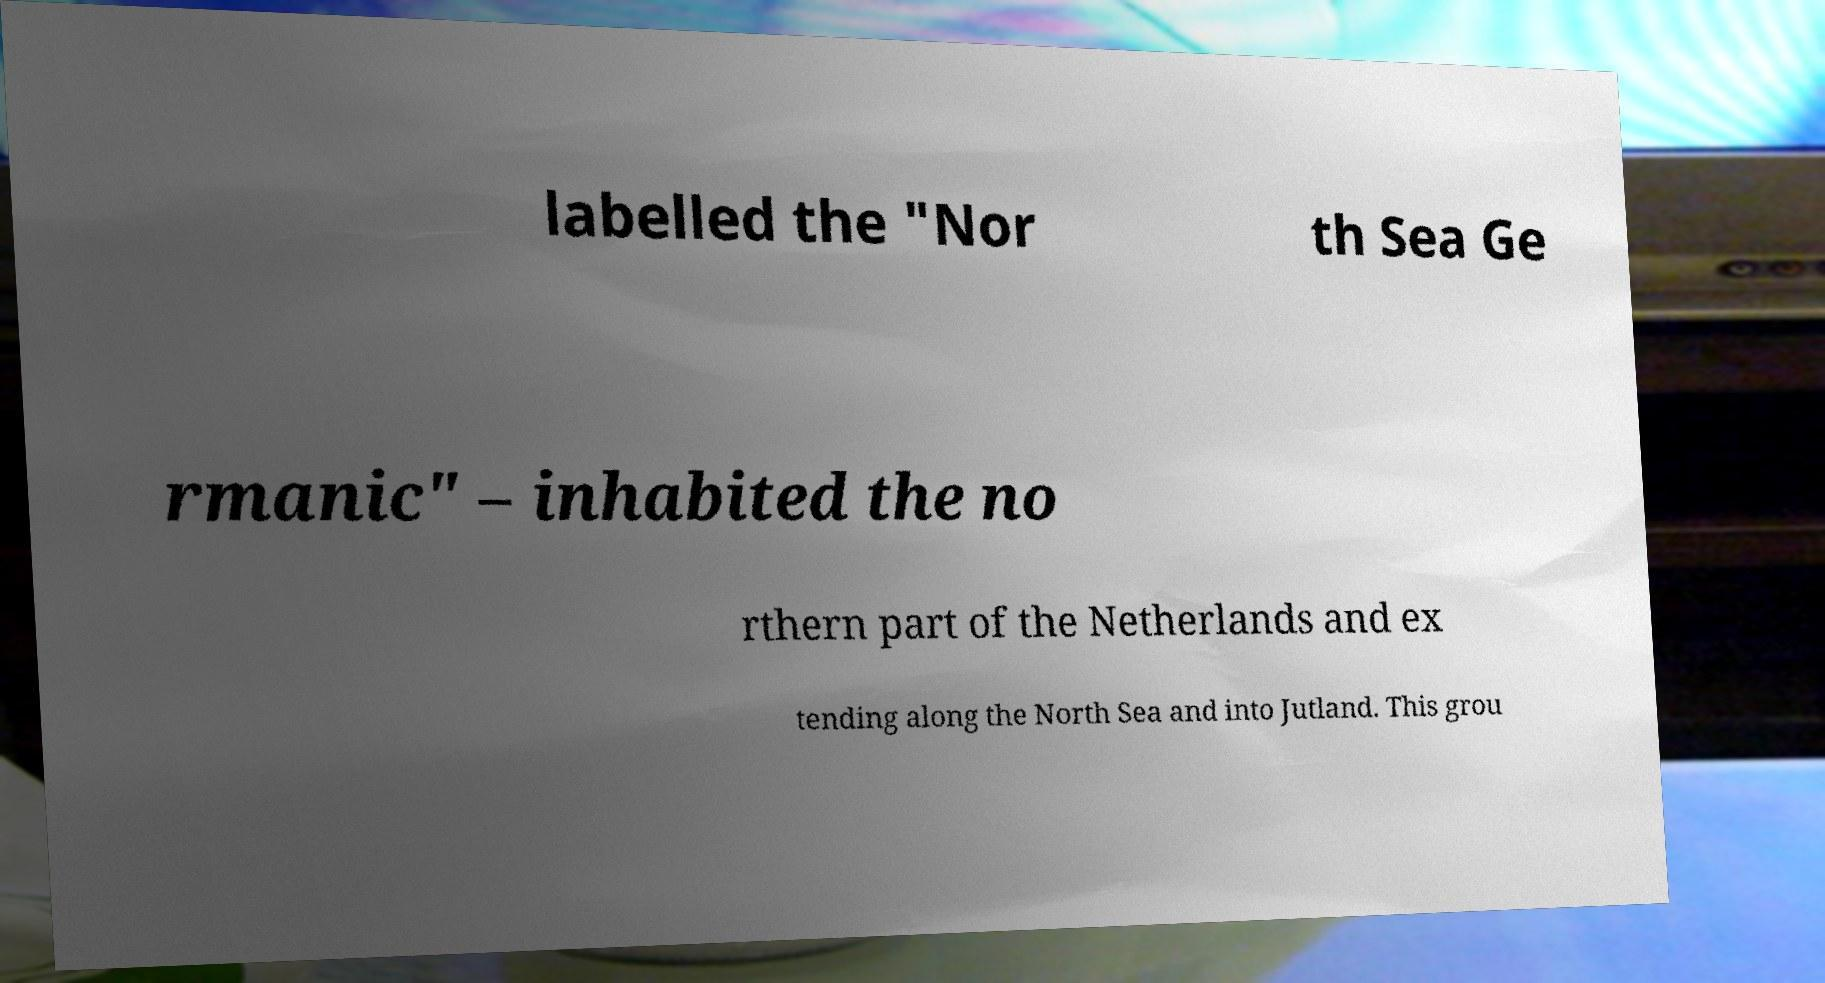There's text embedded in this image that I need extracted. Can you transcribe it verbatim? labelled the "Nor th Sea Ge rmanic" – inhabited the no rthern part of the Netherlands and ex tending along the North Sea and into Jutland. This grou 